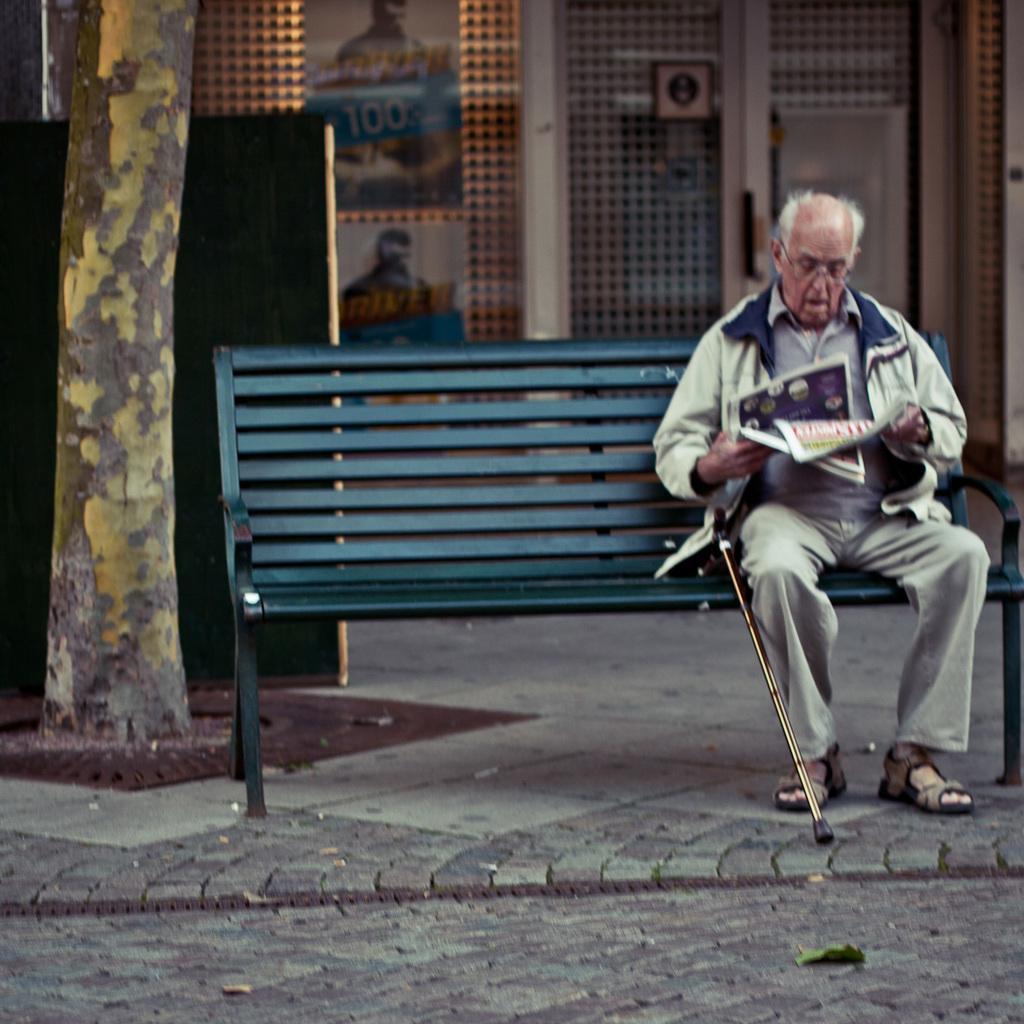In one or two sentences, can you explain what this image depicts? In the image we can see there is a man who is sitting on bench. 